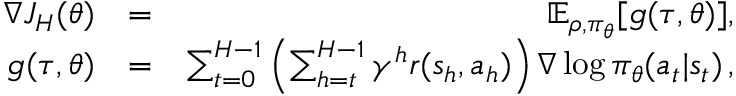<formula> <loc_0><loc_0><loc_500><loc_500>\begin{array} { r l r } { \nabla J _ { H } ( \theta ) } & { = } & { \mathbb { E } _ { \rho , \pi _ { \theta } } [ g ( \tau , \theta ) ] , } \\ { g ( \tau , \theta ) } & { = } & { \sum _ { t = 0 } ^ { H - 1 } \left ( \sum _ { h = t } ^ { H - 1 } \gamma ^ { h } r ( s _ { h } , a _ { h } ) \right ) \nabla \log \pi _ { \theta } ( a _ { t } | s _ { t } ) \, , } \end{array}</formula> 